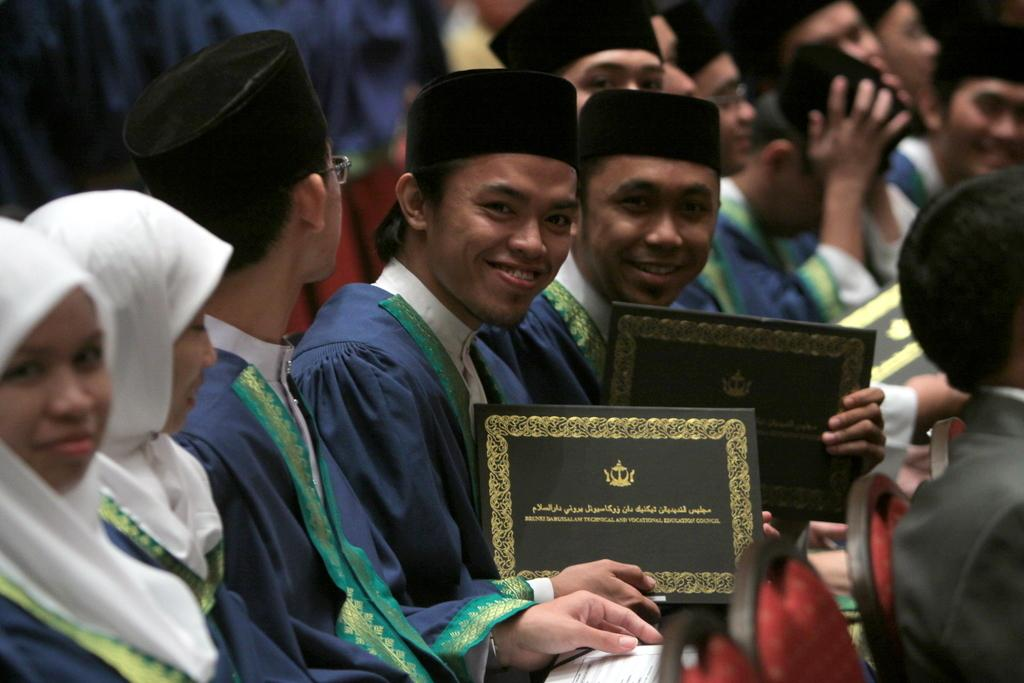How many people are present in the image? There are people in the image, but the exact number cannot be determined from the provided facts. What are the people in the image doing? Some people are holding objects, but the specific objects cannot be identified from the provided facts. What type of furniture is visible in the image? There are chairs in the image. What type of oatmeal is being served on the chairs in the image? There is no oatmeal present in the image; it only mentions people and chairs. How does the change in the image affect the relationship between the people? There is no mention of change or relationships between people in the provided facts, so we cannot answer this question. 